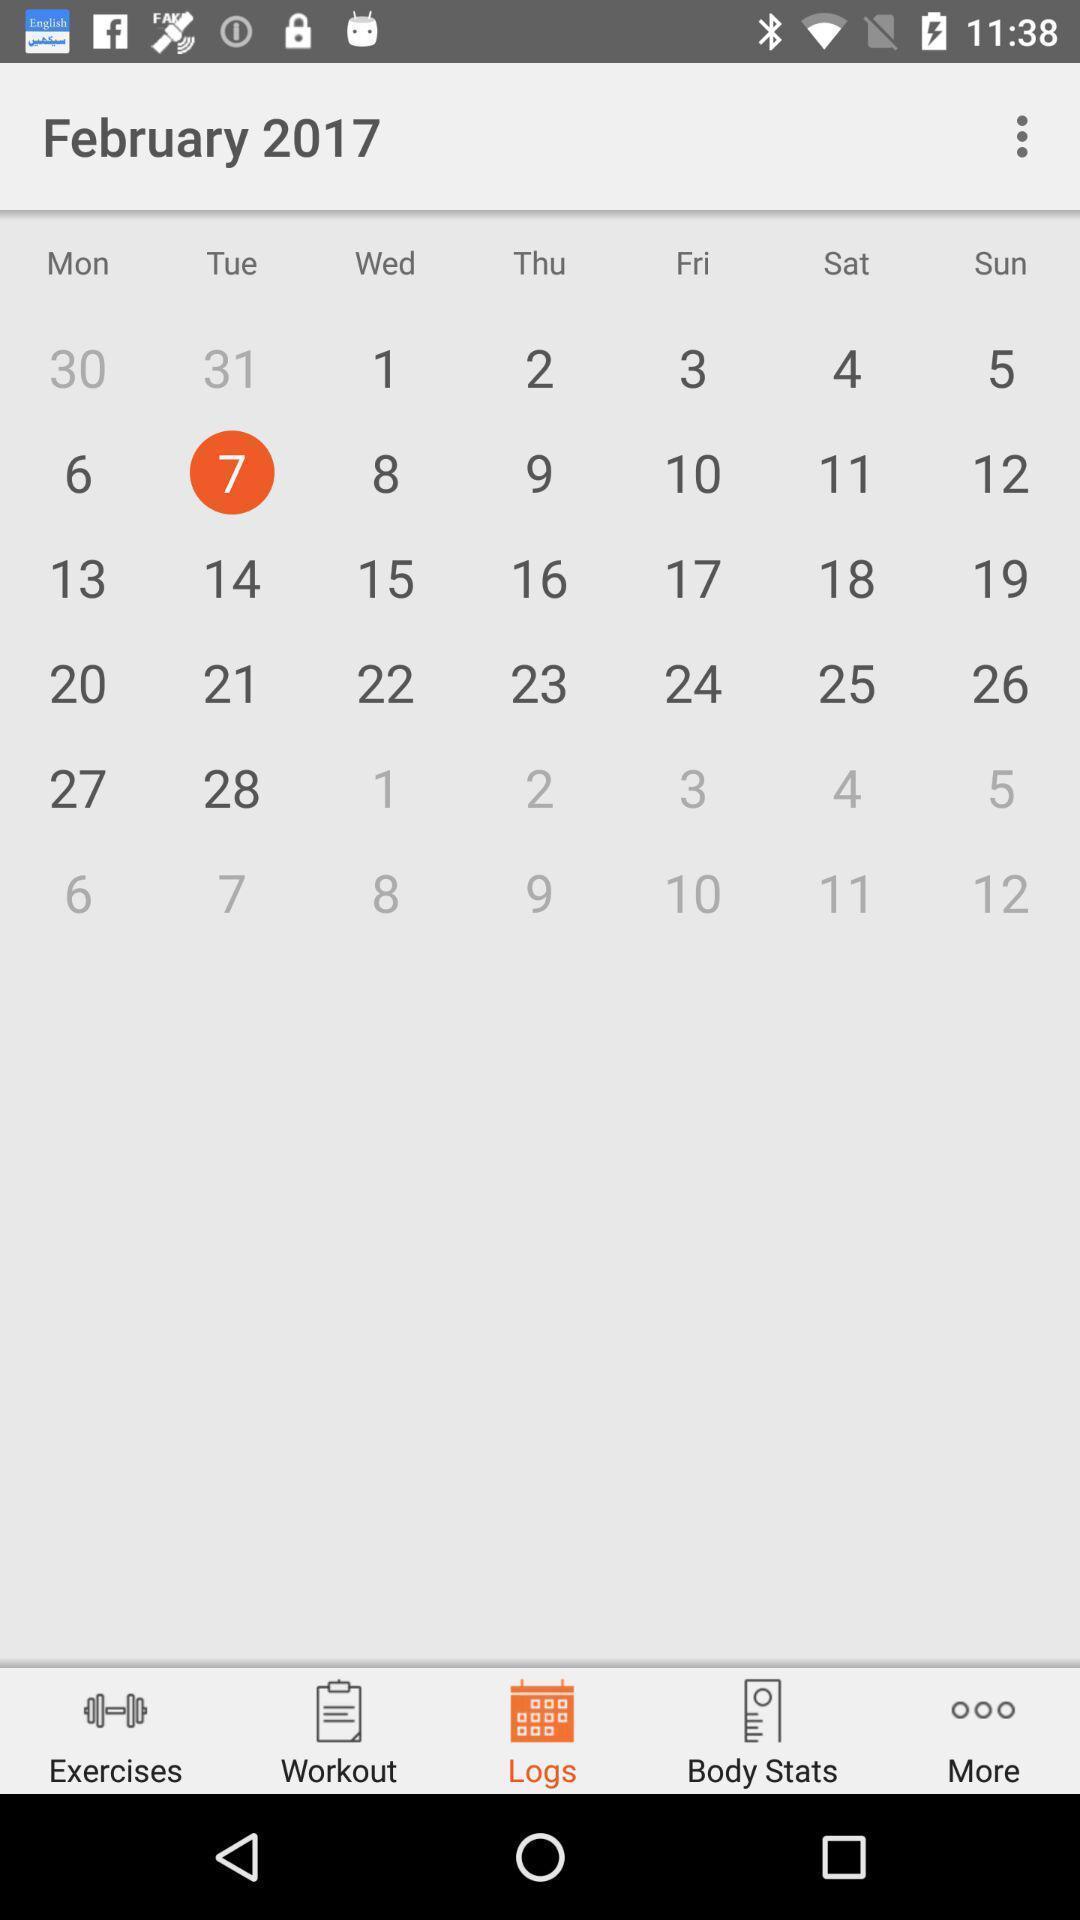Provide a textual representation of this image. Window displaying calendar for fitness app. 